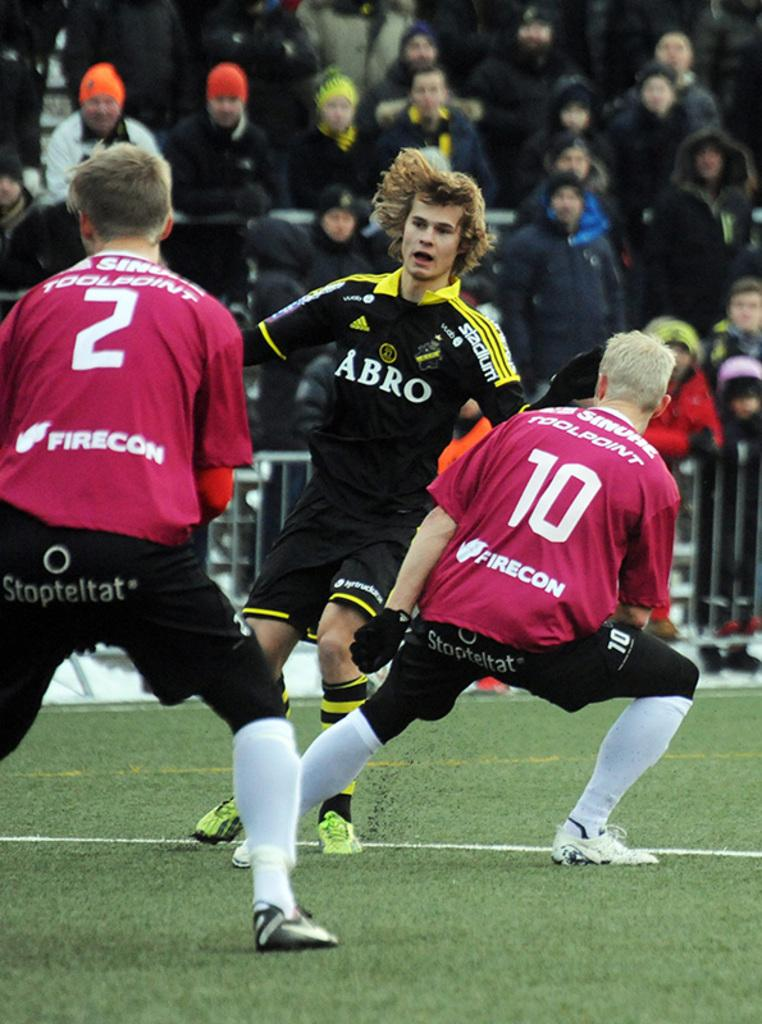How many people are on the ground in the image? There are three people on the ground in the image. What type of surface are the people on? Grass is visible on the ground. What structures can be seen in the image? There are barricades in the image. Can you describe the background of the image? There are people in the background of the image. What color is the elbow of the person in the image? There is no mention of an elbow in the image, as the focus is on the people on the ground and the barricades. 